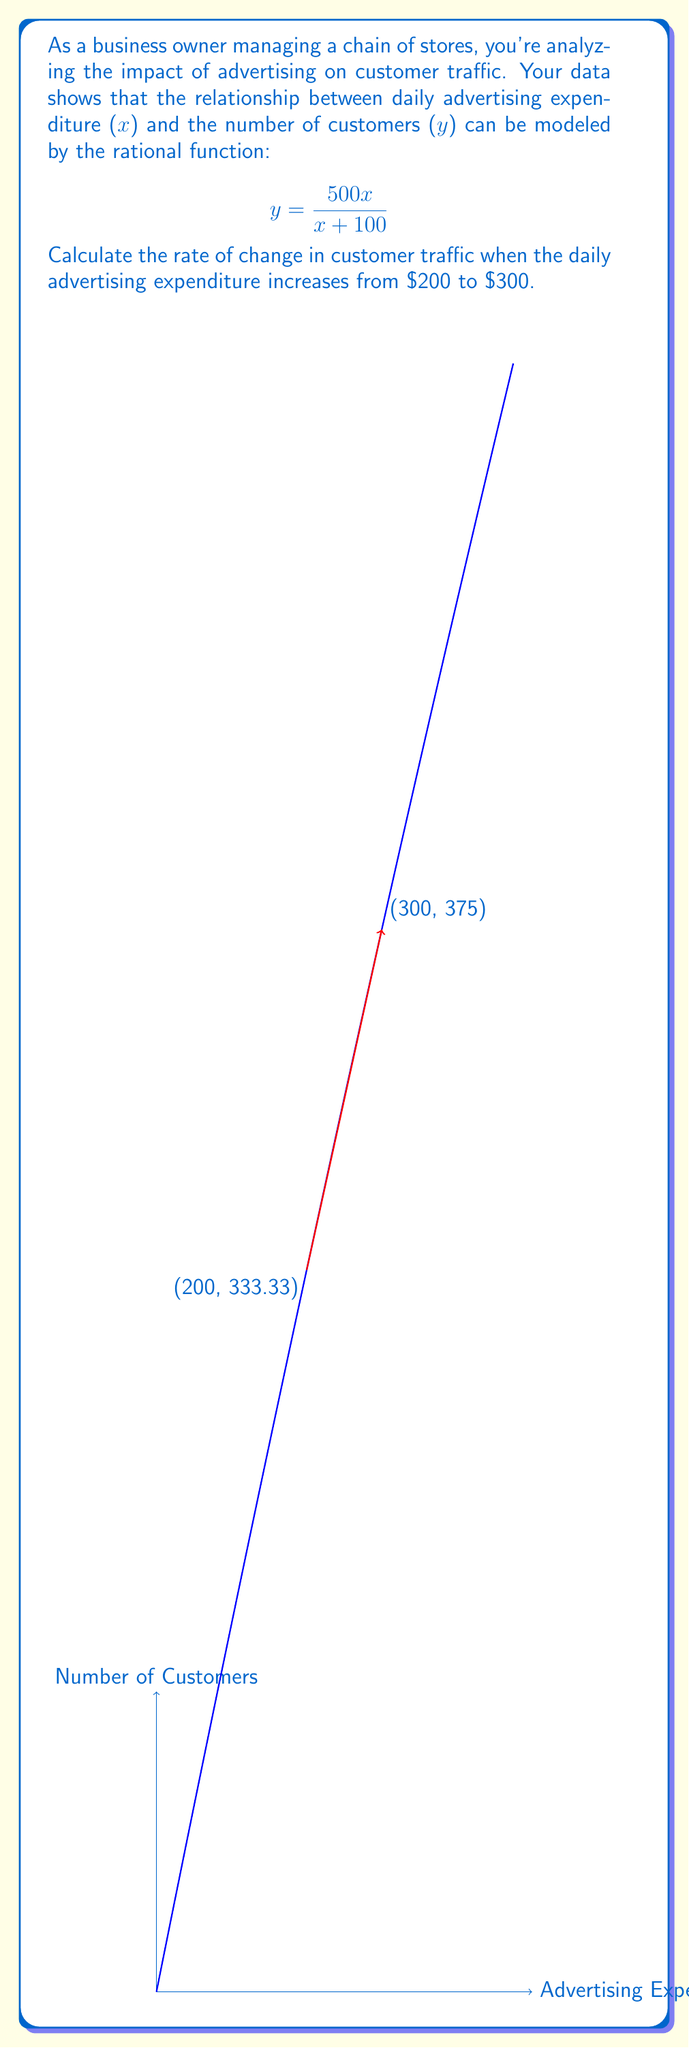Provide a solution to this math problem. To solve this problem, we'll follow these steps:

1) First, let's calculate the number of customers for each advertising expenditure:

   For $x = 200$:
   $$y_1 = \frac{500(200)}{200 + 100} = \frac{100000}{300} = 333.33$$

   For $x = 300$:
   $$y_2 = \frac{500(300)}{300 + 100} = \frac{150000}{400} = 375$$

2) The rate of change is the change in y divided by the change in x:

   $$\text{Rate of change} = \frac{\Delta y}{\Delta x} = \frac{y_2 - y_1}{x_2 - x_1}$$

3) Plugging in our values:

   $$\text{Rate of change} = \frac{375 - 333.33}{300 - 200} = \frac{41.67}{100} = 0.4167$$

4) This means that for every dollar increase in advertising expenditure between $200 and $300, we expect an increase of about 0.4167 customers.
Answer: 0.4167 customers per dollar 